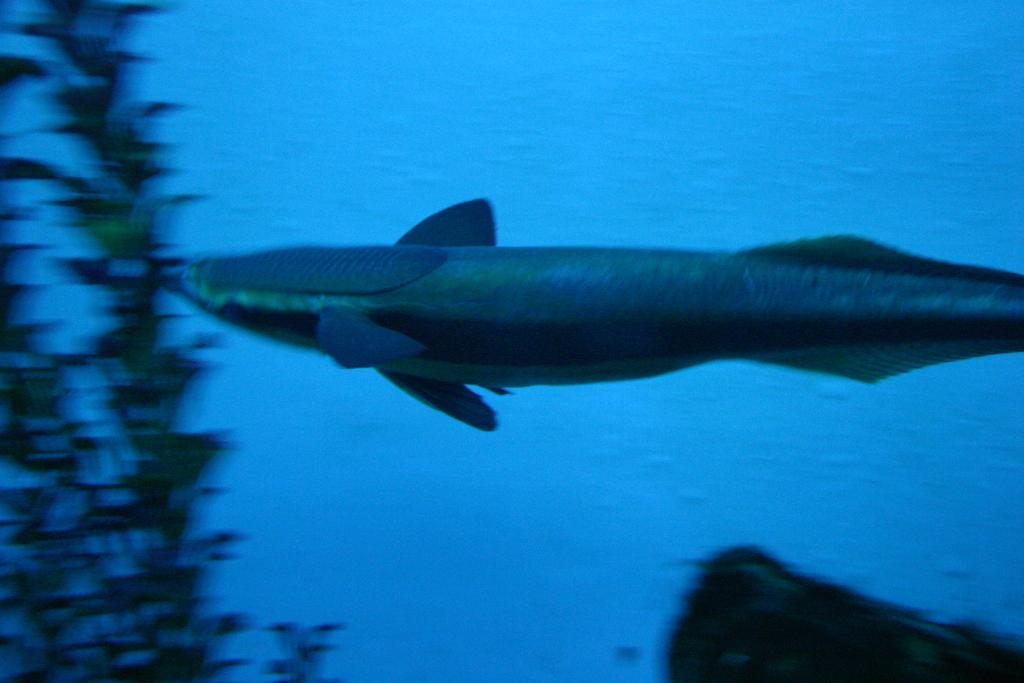What type of animal can be seen in the water in the image? There is a whale in the water in the image. What other object or element can be seen on the right side of the image? There is a plant on the right side of the image. How many brothers does the baby in the image have? There is no baby present in the image, so it is not possible to determine how many brothers the baby might have. 